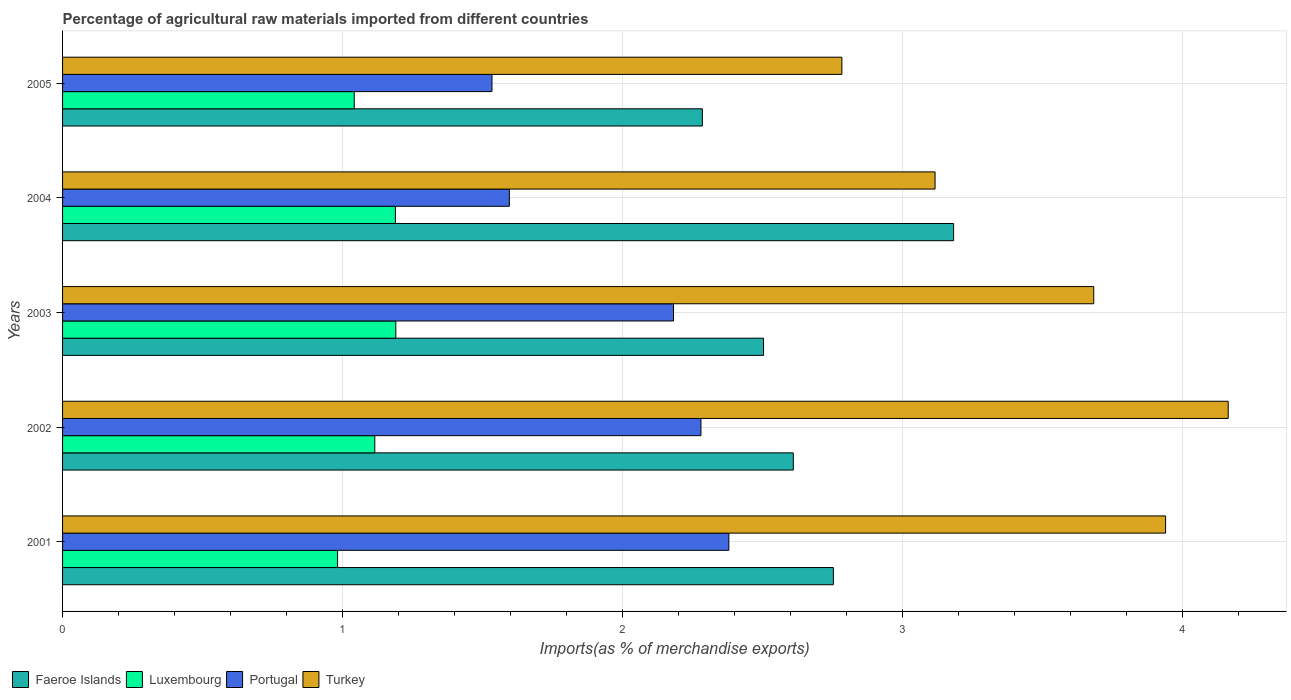How many different coloured bars are there?
Give a very brief answer. 4. Are the number of bars per tick equal to the number of legend labels?
Provide a succinct answer. Yes. Are the number of bars on each tick of the Y-axis equal?
Provide a short and direct response. Yes. How many bars are there on the 4th tick from the bottom?
Offer a very short reply. 4. What is the label of the 5th group of bars from the top?
Your answer should be very brief. 2001. What is the percentage of imports to different countries in Turkey in 2003?
Provide a succinct answer. 3.68. Across all years, what is the maximum percentage of imports to different countries in Faeroe Islands?
Keep it short and to the point. 3.18. Across all years, what is the minimum percentage of imports to different countries in Portugal?
Keep it short and to the point. 1.53. In which year was the percentage of imports to different countries in Luxembourg maximum?
Your answer should be compact. 2003. What is the total percentage of imports to different countries in Turkey in the graph?
Your response must be concise. 17.69. What is the difference between the percentage of imports to different countries in Faeroe Islands in 2002 and that in 2004?
Offer a terse response. -0.57. What is the difference between the percentage of imports to different countries in Turkey in 2001 and the percentage of imports to different countries in Portugal in 2002?
Keep it short and to the point. 1.66. What is the average percentage of imports to different countries in Portugal per year?
Give a very brief answer. 1.99. In the year 2003, what is the difference between the percentage of imports to different countries in Portugal and percentage of imports to different countries in Faeroe Islands?
Offer a terse response. -0.32. In how many years, is the percentage of imports to different countries in Luxembourg greater than 1.4 %?
Make the answer very short. 0. What is the ratio of the percentage of imports to different countries in Turkey in 2002 to that in 2005?
Ensure brevity in your answer.  1.5. Is the percentage of imports to different countries in Portugal in 2001 less than that in 2002?
Offer a very short reply. No. Is the difference between the percentage of imports to different countries in Portugal in 2001 and 2002 greater than the difference between the percentage of imports to different countries in Faeroe Islands in 2001 and 2002?
Make the answer very short. No. What is the difference between the highest and the second highest percentage of imports to different countries in Faeroe Islands?
Offer a very short reply. 0.43. What is the difference between the highest and the lowest percentage of imports to different countries in Faeroe Islands?
Offer a terse response. 0.9. In how many years, is the percentage of imports to different countries in Portugal greater than the average percentage of imports to different countries in Portugal taken over all years?
Keep it short and to the point. 3. Is it the case that in every year, the sum of the percentage of imports to different countries in Turkey and percentage of imports to different countries in Luxembourg is greater than the sum of percentage of imports to different countries in Faeroe Islands and percentage of imports to different countries in Portugal?
Ensure brevity in your answer.  No. What does the 1st bar from the bottom in 2002 represents?
Offer a very short reply. Faeroe Islands. Is it the case that in every year, the sum of the percentage of imports to different countries in Turkey and percentage of imports to different countries in Luxembourg is greater than the percentage of imports to different countries in Portugal?
Your answer should be very brief. Yes. How many bars are there?
Make the answer very short. 20. Are all the bars in the graph horizontal?
Provide a succinct answer. Yes. How many years are there in the graph?
Give a very brief answer. 5. Does the graph contain any zero values?
Your response must be concise. No. Where does the legend appear in the graph?
Give a very brief answer. Bottom left. How many legend labels are there?
Ensure brevity in your answer.  4. What is the title of the graph?
Your answer should be compact. Percentage of agricultural raw materials imported from different countries. What is the label or title of the X-axis?
Offer a very short reply. Imports(as % of merchandise exports). What is the label or title of the Y-axis?
Ensure brevity in your answer.  Years. What is the Imports(as % of merchandise exports) in Faeroe Islands in 2001?
Keep it short and to the point. 2.75. What is the Imports(as % of merchandise exports) in Luxembourg in 2001?
Ensure brevity in your answer.  0.98. What is the Imports(as % of merchandise exports) of Portugal in 2001?
Make the answer very short. 2.38. What is the Imports(as % of merchandise exports) in Turkey in 2001?
Ensure brevity in your answer.  3.94. What is the Imports(as % of merchandise exports) of Faeroe Islands in 2002?
Your response must be concise. 2.61. What is the Imports(as % of merchandise exports) of Luxembourg in 2002?
Provide a succinct answer. 1.12. What is the Imports(as % of merchandise exports) of Portugal in 2002?
Ensure brevity in your answer.  2.28. What is the Imports(as % of merchandise exports) of Turkey in 2002?
Keep it short and to the point. 4.16. What is the Imports(as % of merchandise exports) of Faeroe Islands in 2003?
Provide a succinct answer. 2.5. What is the Imports(as % of merchandise exports) in Luxembourg in 2003?
Provide a short and direct response. 1.19. What is the Imports(as % of merchandise exports) in Portugal in 2003?
Provide a succinct answer. 2.18. What is the Imports(as % of merchandise exports) of Turkey in 2003?
Your response must be concise. 3.68. What is the Imports(as % of merchandise exports) in Faeroe Islands in 2004?
Your answer should be very brief. 3.18. What is the Imports(as % of merchandise exports) in Luxembourg in 2004?
Your response must be concise. 1.19. What is the Imports(as % of merchandise exports) of Portugal in 2004?
Provide a succinct answer. 1.6. What is the Imports(as % of merchandise exports) in Turkey in 2004?
Provide a short and direct response. 3.12. What is the Imports(as % of merchandise exports) of Faeroe Islands in 2005?
Provide a short and direct response. 2.29. What is the Imports(as % of merchandise exports) of Luxembourg in 2005?
Your response must be concise. 1.04. What is the Imports(as % of merchandise exports) of Portugal in 2005?
Your response must be concise. 1.53. What is the Imports(as % of merchandise exports) of Turkey in 2005?
Your answer should be very brief. 2.78. Across all years, what is the maximum Imports(as % of merchandise exports) of Faeroe Islands?
Give a very brief answer. 3.18. Across all years, what is the maximum Imports(as % of merchandise exports) in Luxembourg?
Keep it short and to the point. 1.19. Across all years, what is the maximum Imports(as % of merchandise exports) in Portugal?
Offer a terse response. 2.38. Across all years, what is the maximum Imports(as % of merchandise exports) of Turkey?
Your answer should be compact. 4.16. Across all years, what is the minimum Imports(as % of merchandise exports) in Faeroe Islands?
Your response must be concise. 2.29. Across all years, what is the minimum Imports(as % of merchandise exports) of Luxembourg?
Your answer should be very brief. 0.98. Across all years, what is the minimum Imports(as % of merchandise exports) in Portugal?
Give a very brief answer. 1.53. Across all years, what is the minimum Imports(as % of merchandise exports) of Turkey?
Give a very brief answer. 2.78. What is the total Imports(as % of merchandise exports) of Faeroe Islands in the graph?
Your answer should be compact. 13.34. What is the total Imports(as % of merchandise exports) in Luxembourg in the graph?
Keep it short and to the point. 5.52. What is the total Imports(as % of merchandise exports) of Portugal in the graph?
Keep it short and to the point. 9.97. What is the total Imports(as % of merchandise exports) in Turkey in the graph?
Give a very brief answer. 17.69. What is the difference between the Imports(as % of merchandise exports) of Faeroe Islands in 2001 and that in 2002?
Provide a succinct answer. 0.14. What is the difference between the Imports(as % of merchandise exports) of Luxembourg in 2001 and that in 2002?
Offer a terse response. -0.13. What is the difference between the Imports(as % of merchandise exports) of Portugal in 2001 and that in 2002?
Offer a very short reply. 0.1. What is the difference between the Imports(as % of merchandise exports) in Turkey in 2001 and that in 2002?
Your answer should be compact. -0.22. What is the difference between the Imports(as % of merchandise exports) in Faeroe Islands in 2001 and that in 2003?
Your answer should be compact. 0.25. What is the difference between the Imports(as % of merchandise exports) of Luxembourg in 2001 and that in 2003?
Give a very brief answer. -0.21. What is the difference between the Imports(as % of merchandise exports) of Portugal in 2001 and that in 2003?
Your answer should be compact. 0.2. What is the difference between the Imports(as % of merchandise exports) in Turkey in 2001 and that in 2003?
Give a very brief answer. 0.26. What is the difference between the Imports(as % of merchandise exports) in Faeroe Islands in 2001 and that in 2004?
Make the answer very short. -0.43. What is the difference between the Imports(as % of merchandise exports) of Luxembourg in 2001 and that in 2004?
Offer a very short reply. -0.21. What is the difference between the Imports(as % of merchandise exports) in Portugal in 2001 and that in 2004?
Give a very brief answer. 0.78. What is the difference between the Imports(as % of merchandise exports) in Turkey in 2001 and that in 2004?
Provide a short and direct response. 0.82. What is the difference between the Imports(as % of merchandise exports) of Faeroe Islands in 2001 and that in 2005?
Give a very brief answer. 0.47. What is the difference between the Imports(as % of merchandise exports) in Luxembourg in 2001 and that in 2005?
Offer a terse response. -0.06. What is the difference between the Imports(as % of merchandise exports) in Portugal in 2001 and that in 2005?
Your answer should be very brief. 0.85. What is the difference between the Imports(as % of merchandise exports) in Turkey in 2001 and that in 2005?
Offer a terse response. 1.16. What is the difference between the Imports(as % of merchandise exports) of Faeroe Islands in 2002 and that in 2003?
Offer a very short reply. 0.11. What is the difference between the Imports(as % of merchandise exports) of Luxembourg in 2002 and that in 2003?
Offer a terse response. -0.07. What is the difference between the Imports(as % of merchandise exports) in Portugal in 2002 and that in 2003?
Offer a terse response. 0.1. What is the difference between the Imports(as % of merchandise exports) in Turkey in 2002 and that in 2003?
Give a very brief answer. 0.48. What is the difference between the Imports(as % of merchandise exports) of Faeroe Islands in 2002 and that in 2004?
Keep it short and to the point. -0.57. What is the difference between the Imports(as % of merchandise exports) of Luxembourg in 2002 and that in 2004?
Your answer should be very brief. -0.07. What is the difference between the Imports(as % of merchandise exports) of Portugal in 2002 and that in 2004?
Ensure brevity in your answer.  0.68. What is the difference between the Imports(as % of merchandise exports) in Turkey in 2002 and that in 2004?
Offer a very short reply. 1.05. What is the difference between the Imports(as % of merchandise exports) of Faeroe Islands in 2002 and that in 2005?
Provide a short and direct response. 0.32. What is the difference between the Imports(as % of merchandise exports) of Luxembourg in 2002 and that in 2005?
Make the answer very short. 0.07. What is the difference between the Imports(as % of merchandise exports) in Portugal in 2002 and that in 2005?
Your response must be concise. 0.75. What is the difference between the Imports(as % of merchandise exports) of Turkey in 2002 and that in 2005?
Offer a very short reply. 1.38. What is the difference between the Imports(as % of merchandise exports) of Faeroe Islands in 2003 and that in 2004?
Provide a succinct answer. -0.68. What is the difference between the Imports(as % of merchandise exports) in Luxembourg in 2003 and that in 2004?
Keep it short and to the point. 0. What is the difference between the Imports(as % of merchandise exports) in Portugal in 2003 and that in 2004?
Provide a short and direct response. 0.59. What is the difference between the Imports(as % of merchandise exports) in Turkey in 2003 and that in 2004?
Give a very brief answer. 0.57. What is the difference between the Imports(as % of merchandise exports) of Faeroe Islands in 2003 and that in 2005?
Provide a succinct answer. 0.22. What is the difference between the Imports(as % of merchandise exports) in Luxembourg in 2003 and that in 2005?
Make the answer very short. 0.15. What is the difference between the Imports(as % of merchandise exports) in Portugal in 2003 and that in 2005?
Your answer should be compact. 0.65. What is the difference between the Imports(as % of merchandise exports) of Turkey in 2003 and that in 2005?
Provide a short and direct response. 0.9. What is the difference between the Imports(as % of merchandise exports) in Faeroe Islands in 2004 and that in 2005?
Offer a very short reply. 0.9. What is the difference between the Imports(as % of merchandise exports) in Luxembourg in 2004 and that in 2005?
Offer a very short reply. 0.15. What is the difference between the Imports(as % of merchandise exports) in Portugal in 2004 and that in 2005?
Give a very brief answer. 0.06. What is the difference between the Imports(as % of merchandise exports) in Turkey in 2004 and that in 2005?
Provide a short and direct response. 0.33. What is the difference between the Imports(as % of merchandise exports) of Faeroe Islands in 2001 and the Imports(as % of merchandise exports) of Luxembourg in 2002?
Give a very brief answer. 1.64. What is the difference between the Imports(as % of merchandise exports) of Faeroe Islands in 2001 and the Imports(as % of merchandise exports) of Portugal in 2002?
Your answer should be very brief. 0.47. What is the difference between the Imports(as % of merchandise exports) in Faeroe Islands in 2001 and the Imports(as % of merchandise exports) in Turkey in 2002?
Ensure brevity in your answer.  -1.41. What is the difference between the Imports(as % of merchandise exports) in Luxembourg in 2001 and the Imports(as % of merchandise exports) in Portugal in 2002?
Offer a terse response. -1.3. What is the difference between the Imports(as % of merchandise exports) in Luxembourg in 2001 and the Imports(as % of merchandise exports) in Turkey in 2002?
Your answer should be very brief. -3.18. What is the difference between the Imports(as % of merchandise exports) in Portugal in 2001 and the Imports(as % of merchandise exports) in Turkey in 2002?
Offer a very short reply. -1.78. What is the difference between the Imports(as % of merchandise exports) in Faeroe Islands in 2001 and the Imports(as % of merchandise exports) in Luxembourg in 2003?
Provide a succinct answer. 1.56. What is the difference between the Imports(as % of merchandise exports) of Faeroe Islands in 2001 and the Imports(as % of merchandise exports) of Portugal in 2003?
Your response must be concise. 0.57. What is the difference between the Imports(as % of merchandise exports) in Faeroe Islands in 2001 and the Imports(as % of merchandise exports) in Turkey in 2003?
Offer a terse response. -0.93. What is the difference between the Imports(as % of merchandise exports) of Luxembourg in 2001 and the Imports(as % of merchandise exports) of Turkey in 2003?
Give a very brief answer. -2.7. What is the difference between the Imports(as % of merchandise exports) in Portugal in 2001 and the Imports(as % of merchandise exports) in Turkey in 2003?
Keep it short and to the point. -1.3. What is the difference between the Imports(as % of merchandise exports) of Faeroe Islands in 2001 and the Imports(as % of merchandise exports) of Luxembourg in 2004?
Offer a terse response. 1.56. What is the difference between the Imports(as % of merchandise exports) of Faeroe Islands in 2001 and the Imports(as % of merchandise exports) of Portugal in 2004?
Your answer should be very brief. 1.16. What is the difference between the Imports(as % of merchandise exports) of Faeroe Islands in 2001 and the Imports(as % of merchandise exports) of Turkey in 2004?
Your answer should be very brief. -0.36. What is the difference between the Imports(as % of merchandise exports) in Luxembourg in 2001 and the Imports(as % of merchandise exports) in Portugal in 2004?
Keep it short and to the point. -0.61. What is the difference between the Imports(as % of merchandise exports) in Luxembourg in 2001 and the Imports(as % of merchandise exports) in Turkey in 2004?
Your response must be concise. -2.13. What is the difference between the Imports(as % of merchandise exports) of Portugal in 2001 and the Imports(as % of merchandise exports) of Turkey in 2004?
Ensure brevity in your answer.  -0.74. What is the difference between the Imports(as % of merchandise exports) of Faeroe Islands in 2001 and the Imports(as % of merchandise exports) of Luxembourg in 2005?
Ensure brevity in your answer.  1.71. What is the difference between the Imports(as % of merchandise exports) in Faeroe Islands in 2001 and the Imports(as % of merchandise exports) in Portugal in 2005?
Your answer should be very brief. 1.22. What is the difference between the Imports(as % of merchandise exports) in Faeroe Islands in 2001 and the Imports(as % of merchandise exports) in Turkey in 2005?
Offer a very short reply. -0.03. What is the difference between the Imports(as % of merchandise exports) of Luxembourg in 2001 and the Imports(as % of merchandise exports) of Portugal in 2005?
Ensure brevity in your answer.  -0.55. What is the difference between the Imports(as % of merchandise exports) in Luxembourg in 2001 and the Imports(as % of merchandise exports) in Turkey in 2005?
Offer a terse response. -1.8. What is the difference between the Imports(as % of merchandise exports) in Portugal in 2001 and the Imports(as % of merchandise exports) in Turkey in 2005?
Your answer should be very brief. -0.4. What is the difference between the Imports(as % of merchandise exports) of Faeroe Islands in 2002 and the Imports(as % of merchandise exports) of Luxembourg in 2003?
Make the answer very short. 1.42. What is the difference between the Imports(as % of merchandise exports) of Faeroe Islands in 2002 and the Imports(as % of merchandise exports) of Portugal in 2003?
Provide a succinct answer. 0.43. What is the difference between the Imports(as % of merchandise exports) in Faeroe Islands in 2002 and the Imports(as % of merchandise exports) in Turkey in 2003?
Offer a terse response. -1.07. What is the difference between the Imports(as % of merchandise exports) of Luxembourg in 2002 and the Imports(as % of merchandise exports) of Portugal in 2003?
Your response must be concise. -1.07. What is the difference between the Imports(as % of merchandise exports) of Luxembourg in 2002 and the Imports(as % of merchandise exports) of Turkey in 2003?
Make the answer very short. -2.57. What is the difference between the Imports(as % of merchandise exports) in Portugal in 2002 and the Imports(as % of merchandise exports) in Turkey in 2003?
Your answer should be very brief. -1.4. What is the difference between the Imports(as % of merchandise exports) in Faeroe Islands in 2002 and the Imports(as % of merchandise exports) in Luxembourg in 2004?
Your answer should be compact. 1.42. What is the difference between the Imports(as % of merchandise exports) in Faeroe Islands in 2002 and the Imports(as % of merchandise exports) in Portugal in 2004?
Keep it short and to the point. 1.01. What is the difference between the Imports(as % of merchandise exports) of Faeroe Islands in 2002 and the Imports(as % of merchandise exports) of Turkey in 2004?
Keep it short and to the point. -0.51. What is the difference between the Imports(as % of merchandise exports) of Luxembourg in 2002 and the Imports(as % of merchandise exports) of Portugal in 2004?
Your response must be concise. -0.48. What is the difference between the Imports(as % of merchandise exports) of Luxembourg in 2002 and the Imports(as % of merchandise exports) of Turkey in 2004?
Give a very brief answer. -2. What is the difference between the Imports(as % of merchandise exports) of Portugal in 2002 and the Imports(as % of merchandise exports) of Turkey in 2004?
Your response must be concise. -0.84. What is the difference between the Imports(as % of merchandise exports) in Faeroe Islands in 2002 and the Imports(as % of merchandise exports) in Luxembourg in 2005?
Offer a very short reply. 1.57. What is the difference between the Imports(as % of merchandise exports) of Faeroe Islands in 2002 and the Imports(as % of merchandise exports) of Portugal in 2005?
Ensure brevity in your answer.  1.08. What is the difference between the Imports(as % of merchandise exports) of Faeroe Islands in 2002 and the Imports(as % of merchandise exports) of Turkey in 2005?
Keep it short and to the point. -0.17. What is the difference between the Imports(as % of merchandise exports) in Luxembourg in 2002 and the Imports(as % of merchandise exports) in Portugal in 2005?
Make the answer very short. -0.42. What is the difference between the Imports(as % of merchandise exports) in Luxembourg in 2002 and the Imports(as % of merchandise exports) in Turkey in 2005?
Your answer should be compact. -1.67. What is the difference between the Imports(as % of merchandise exports) of Portugal in 2002 and the Imports(as % of merchandise exports) of Turkey in 2005?
Offer a terse response. -0.5. What is the difference between the Imports(as % of merchandise exports) in Faeroe Islands in 2003 and the Imports(as % of merchandise exports) in Luxembourg in 2004?
Offer a terse response. 1.31. What is the difference between the Imports(as % of merchandise exports) in Faeroe Islands in 2003 and the Imports(as % of merchandise exports) in Portugal in 2004?
Your answer should be compact. 0.91. What is the difference between the Imports(as % of merchandise exports) in Faeroe Islands in 2003 and the Imports(as % of merchandise exports) in Turkey in 2004?
Give a very brief answer. -0.61. What is the difference between the Imports(as % of merchandise exports) in Luxembourg in 2003 and the Imports(as % of merchandise exports) in Portugal in 2004?
Offer a very short reply. -0.41. What is the difference between the Imports(as % of merchandise exports) in Luxembourg in 2003 and the Imports(as % of merchandise exports) in Turkey in 2004?
Give a very brief answer. -1.93. What is the difference between the Imports(as % of merchandise exports) of Portugal in 2003 and the Imports(as % of merchandise exports) of Turkey in 2004?
Ensure brevity in your answer.  -0.93. What is the difference between the Imports(as % of merchandise exports) in Faeroe Islands in 2003 and the Imports(as % of merchandise exports) in Luxembourg in 2005?
Your response must be concise. 1.46. What is the difference between the Imports(as % of merchandise exports) of Faeroe Islands in 2003 and the Imports(as % of merchandise exports) of Portugal in 2005?
Provide a short and direct response. 0.97. What is the difference between the Imports(as % of merchandise exports) of Faeroe Islands in 2003 and the Imports(as % of merchandise exports) of Turkey in 2005?
Provide a succinct answer. -0.28. What is the difference between the Imports(as % of merchandise exports) in Luxembourg in 2003 and the Imports(as % of merchandise exports) in Portugal in 2005?
Your response must be concise. -0.34. What is the difference between the Imports(as % of merchandise exports) of Luxembourg in 2003 and the Imports(as % of merchandise exports) of Turkey in 2005?
Ensure brevity in your answer.  -1.59. What is the difference between the Imports(as % of merchandise exports) in Portugal in 2003 and the Imports(as % of merchandise exports) in Turkey in 2005?
Provide a short and direct response. -0.6. What is the difference between the Imports(as % of merchandise exports) of Faeroe Islands in 2004 and the Imports(as % of merchandise exports) of Luxembourg in 2005?
Your answer should be compact. 2.14. What is the difference between the Imports(as % of merchandise exports) of Faeroe Islands in 2004 and the Imports(as % of merchandise exports) of Portugal in 2005?
Your answer should be compact. 1.65. What is the difference between the Imports(as % of merchandise exports) in Faeroe Islands in 2004 and the Imports(as % of merchandise exports) in Turkey in 2005?
Give a very brief answer. 0.4. What is the difference between the Imports(as % of merchandise exports) of Luxembourg in 2004 and the Imports(as % of merchandise exports) of Portugal in 2005?
Offer a terse response. -0.34. What is the difference between the Imports(as % of merchandise exports) in Luxembourg in 2004 and the Imports(as % of merchandise exports) in Turkey in 2005?
Make the answer very short. -1.59. What is the difference between the Imports(as % of merchandise exports) of Portugal in 2004 and the Imports(as % of merchandise exports) of Turkey in 2005?
Make the answer very short. -1.19. What is the average Imports(as % of merchandise exports) in Faeroe Islands per year?
Your answer should be compact. 2.67. What is the average Imports(as % of merchandise exports) in Luxembourg per year?
Provide a succinct answer. 1.1. What is the average Imports(as % of merchandise exports) in Portugal per year?
Your answer should be compact. 1.99. What is the average Imports(as % of merchandise exports) in Turkey per year?
Give a very brief answer. 3.54. In the year 2001, what is the difference between the Imports(as % of merchandise exports) of Faeroe Islands and Imports(as % of merchandise exports) of Luxembourg?
Make the answer very short. 1.77. In the year 2001, what is the difference between the Imports(as % of merchandise exports) of Faeroe Islands and Imports(as % of merchandise exports) of Portugal?
Ensure brevity in your answer.  0.37. In the year 2001, what is the difference between the Imports(as % of merchandise exports) in Faeroe Islands and Imports(as % of merchandise exports) in Turkey?
Keep it short and to the point. -1.19. In the year 2001, what is the difference between the Imports(as % of merchandise exports) in Luxembourg and Imports(as % of merchandise exports) in Portugal?
Ensure brevity in your answer.  -1.4. In the year 2001, what is the difference between the Imports(as % of merchandise exports) in Luxembourg and Imports(as % of merchandise exports) in Turkey?
Give a very brief answer. -2.96. In the year 2001, what is the difference between the Imports(as % of merchandise exports) in Portugal and Imports(as % of merchandise exports) in Turkey?
Ensure brevity in your answer.  -1.56. In the year 2002, what is the difference between the Imports(as % of merchandise exports) of Faeroe Islands and Imports(as % of merchandise exports) of Luxembourg?
Provide a succinct answer. 1.49. In the year 2002, what is the difference between the Imports(as % of merchandise exports) in Faeroe Islands and Imports(as % of merchandise exports) in Portugal?
Ensure brevity in your answer.  0.33. In the year 2002, what is the difference between the Imports(as % of merchandise exports) in Faeroe Islands and Imports(as % of merchandise exports) in Turkey?
Offer a terse response. -1.55. In the year 2002, what is the difference between the Imports(as % of merchandise exports) of Luxembourg and Imports(as % of merchandise exports) of Portugal?
Make the answer very short. -1.16. In the year 2002, what is the difference between the Imports(as % of merchandise exports) of Luxembourg and Imports(as % of merchandise exports) of Turkey?
Provide a short and direct response. -3.05. In the year 2002, what is the difference between the Imports(as % of merchandise exports) of Portugal and Imports(as % of merchandise exports) of Turkey?
Offer a terse response. -1.88. In the year 2003, what is the difference between the Imports(as % of merchandise exports) of Faeroe Islands and Imports(as % of merchandise exports) of Luxembourg?
Keep it short and to the point. 1.31. In the year 2003, what is the difference between the Imports(as % of merchandise exports) of Faeroe Islands and Imports(as % of merchandise exports) of Portugal?
Keep it short and to the point. 0.32. In the year 2003, what is the difference between the Imports(as % of merchandise exports) of Faeroe Islands and Imports(as % of merchandise exports) of Turkey?
Your answer should be very brief. -1.18. In the year 2003, what is the difference between the Imports(as % of merchandise exports) of Luxembourg and Imports(as % of merchandise exports) of Portugal?
Your answer should be compact. -0.99. In the year 2003, what is the difference between the Imports(as % of merchandise exports) of Luxembourg and Imports(as % of merchandise exports) of Turkey?
Provide a succinct answer. -2.49. In the year 2003, what is the difference between the Imports(as % of merchandise exports) of Portugal and Imports(as % of merchandise exports) of Turkey?
Provide a succinct answer. -1.5. In the year 2004, what is the difference between the Imports(as % of merchandise exports) of Faeroe Islands and Imports(as % of merchandise exports) of Luxembourg?
Keep it short and to the point. 1.99. In the year 2004, what is the difference between the Imports(as % of merchandise exports) in Faeroe Islands and Imports(as % of merchandise exports) in Portugal?
Keep it short and to the point. 1.59. In the year 2004, what is the difference between the Imports(as % of merchandise exports) of Faeroe Islands and Imports(as % of merchandise exports) of Turkey?
Your answer should be compact. 0.07. In the year 2004, what is the difference between the Imports(as % of merchandise exports) in Luxembourg and Imports(as % of merchandise exports) in Portugal?
Ensure brevity in your answer.  -0.41. In the year 2004, what is the difference between the Imports(as % of merchandise exports) in Luxembourg and Imports(as % of merchandise exports) in Turkey?
Your response must be concise. -1.93. In the year 2004, what is the difference between the Imports(as % of merchandise exports) in Portugal and Imports(as % of merchandise exports) in Turkey?
Offer a very short reply. -1.52. In the year 2005, what is the difference between the Imports(as % of merchandise exports) of Faeroe Islands and Imports(as % of merchandise exports) of Luxembourg?
Your answer should be compact. 1.24. In the year 2005, what is the difference between the Imports(as % of merchandise exports) of Faeroe Islands and Imports(as % of merchandise exports) of Portugal?
Offer a very short reply. 0.75. In the year 2005, what is the difference between the Imports(as % of merchandise exports) in Faeroe Islands and Imports(as % of merchandise exports) in Turkey?
Provide a succinct answer. -0.5. In the year 2005, what is the difference between the Imports(as % of merchandise exports) of Luxembourg and Imports(as % of merchandise exports) of Portugal?
Provide a short and direct response. -0.49. In the year 2005, what is the difference between the Imports(as % of merchandise exports) of Luxembourg and Imports(as % of merchandise exports) of Turkey?
Make the answer very short. -1.74. In the year 2005, what is the difference between the Imports(as % of merchandise exports) of Portugal and Imports(as % of merchandise exports) of Turkey?
Provide a succinct answer. -1.25. What is the ratio of the Imports(as % of merchandise exports) in Faeroe Islands in 2001 to that in 2002?
Make the answer very short. 1.05. What is the ratio of the Imports(as % of merchandise exports) of Luxembourg in 2001 to that in 2002?
Your answer should be very brief. 0.88. What is the ratio of the Imports(as % of merchandise exports) of Portugal in 2001 to that in 2002?
Your answer should be very brief. 1.04. What is the ratio of the Imports(as % of merchandise exports) of Turkey in 2001 to that in 2002?
Ensure brevity in your answer.  0.95. What is the ratio of the Imports(as % of merchandise exports) in Faeroe Islands in 2001 to that in 2003?
Give a very brief answer. 1.1. What is the ratio of the Imports(as % of merchandise exports) of Luxembourg in 2001 to that in 2003?
Offer a terse response. 0.83. What is the ratio of the Imports(as % of merchandise exports) of Portugal in 2001 to that in 2003?
Your answer should be very brief. 1.09. What is the ratio of the Imports(as % of merchandise exports) of Turkey in 2001 to that in 2003?
Your answer should be compact. 1.07. What is the ratio of the Imports(as % of merchandise exports) in Faeroe Islands in 2001 to that in 2004?
Ensure brevity in your answer.  0.86. What is the ratio of the Imports(as % of merchandise exports) of Luxembourg in 2001 to that in 2004?
Offer a very short reply. 0.83. What is the ratio of the Imports(as % of merchandise exports) in Portugal in 2001 to that in 2004?
Offer a terse response. 1.49. What is the ratio of the Imports(as % of merchandise exports) in Turkey in 2001 to that in 2004?
Ensure brevity in your answer.  1.26. What is the ratio of the Imports(as % of merchandise exports) of Faeroe Islands in 2001 to that in 2005?
Your answer should be very brief. 1.2. What is the ratio of the Imports(as % of merchandise exports) of Luxembourg in 2001 to that in 2005?
Keep it short and to the point. 0.94. What is the ratio of the Imports(as % of merchandise exports) of Portugal in 2001 to that in 2005?
Your response must be concise. 1.55. What is the ratio of the Imports(as % of merchandise exports) of Turkey in 2001 to that in 2005?
Your answer should be compact. 1.42. What is the ratio of the Imports(as % of merchandise exports) of Faeroe Islands in 2002 to that in 2003?
Provide a succinct answer. 1.04. What is the ratio of the Imports(as % of merchandise exports) of Luxembourg in 2002 to that in 2003?
Your answer should be compact. 0.94. What is the ratio of the Imports(as % of merchandise exports) in Portugal in 2002 to that in 2003?
Make the answer very short. 1.04. What is the ratio of the Imports(as % of merchandise exports) of Turkey in 2002 to that in 2003?
Ensure brevity in your answer.  1.13. What is the ratio of the Imports(as % of merchandise exports) in Faeroe Islands in 2002 to that in 2004?
Provide a succinct answer. 0.82. What is the ratio of the Imports(as % of merchandise exports) in Luxembourg in 2002 to that in 2004?
Ensure brevity in your answer.  0.94. What is the ratio of the Imports(as % of merchandise exports) in Portugal in 2002 to that in 2004?
Offer a terse response. 1.43. What is the ratio of the Imports(as % of merchandise exports) in Turkey in 2002 to that in 2004?
Make the answer very short. 1.34. What is the ratio of the Imports(as % of merchandise exports) in Faeroe Islands in 2002 to that in 2005?
Provide a succinct answer. 1.14. What is the ratio of the Imports(as % of merchandise exports) in Luxembourg in 2002 to that in 2005?
Your answer should be compact. 1.07. What is the ratio of the Imports(as % of merchandise exports) in Portugal in 2002 to that in 2005?
Offer a terse response. 1.49. What is the ratio of the Imports(as % of merchandise exports) in Turkey in 2002 to that in 2005?
Make the answer very short. 1.5. What is the ratio of the Imports(as % of merchandise exports) of Faeroe Islands in 2003 to that in 2004?
Keep it short and to the point. 0.79. What is the ratio of the Imports(as % of merchandise exports) of Luxembourg in 2003 to that in 2004?
Your answer should be compact. 1. What is the ratio of the Imports(as % of merchandise exports) of Portugal in 2003 to that in 2004?
Keep it short and to the point. 1.37. What is the ratio of the Imports(as % of merchandise exports) of Turkey in 2003 to that in 2004?
Ensure brevity in your answer.  1.18. What is the ratio of the Imports(as % of merchandise exports) in Faeroe Islands in 2003 to that in 2005?
Your response must be concise. 1.1. What is the ratio of the Imports(as % of merchandise exports) in Luxembourg in 2003 to that in 2005?
Your answer should be compact. 1.14. What is the ratio of the Imports(as % of merchandise exports) of Portugal in 2003 to that in 2005?
Provide a short and direct response. 1.42. What is the ratio of the Imports(as % of merchandise exports) of Turkey in 2003 to that in 2005?
Provide a succinct answer. 1.32. What is the ratio of the Imports(as % of merchandise exports) of Faeroe Islands in 2004 to that in 2005?
Your answer should be very brief. 1.39. What is the ratio of the Imports(as % of merchandise exports) in Luxembourg in 2004 to that in 2005?
Offer a terse response. 1.14. What is the ratio of the Imports(as % of merchandise exports) in Portugal in 2004 to that in 2005?
Offer a very short reply. 1.04. What is the ratio of the Imports(as % of merchandise exports) in Turkey in 2004 to that in 2005?
Give a very brief answer. 1.12. What is the difference between the highest and the second highest Imports(as % of merchandise exports) in Faeroe Islands?
Offer a terse response. 0.43. What is the difference between the highest and the second highest Imports(as % of merchandise exports) of Luxembourg?
Give a very brief answer. 0. What is the difference between the highest and the second highest Imports(as % of merchandise exports) in Portugal?
Provide a short and direct response. 0.1. What is the difference between the highest and the second highest Imports(as % of merchandise exports) in Turkey?
Offer a terse response. 0.22. What is the difference between the highest and the lowest Imports(as % of merchandise exports) of Faeroe Islands?
Provide a succinct answer. 0.9. What is the difference between the highest and the lowest Imports(as % of merchandise exports) of Luxembourg?
Offer a terse response. 0.21. What is the difference between the highest and the lowest Imports(as % of merchandise exports) of Portugal?
Your response must be concise. 0.85. What is the difference between the highest and the lowest Imports(as % of merchandise exports) of Turkey?
Offer a terse response. 1.38. 